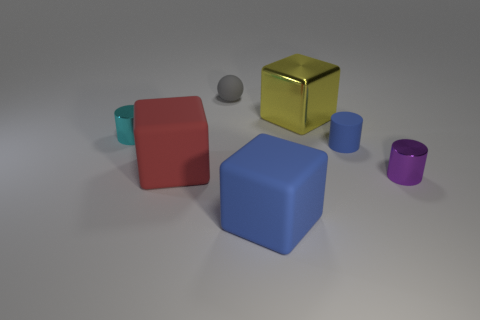Subtract all metal cylinders. How many cylinders are left? 1 Subtract 1 blocks. How many blocks are left? 2 Add 2 rubber cubes. How many objects exist? 9 Subtract all spheres. How many objects are left? 6 Add 7 tiny gray things. How many tiny gray things exist? 8 Subtract 1 blue blocks. How many objects are left? 6 Subtract all small green things. Subtract all large yellow things. How many objects are left? 6 Add 7 purple cylinders. How many purple cylinders are left? 8 